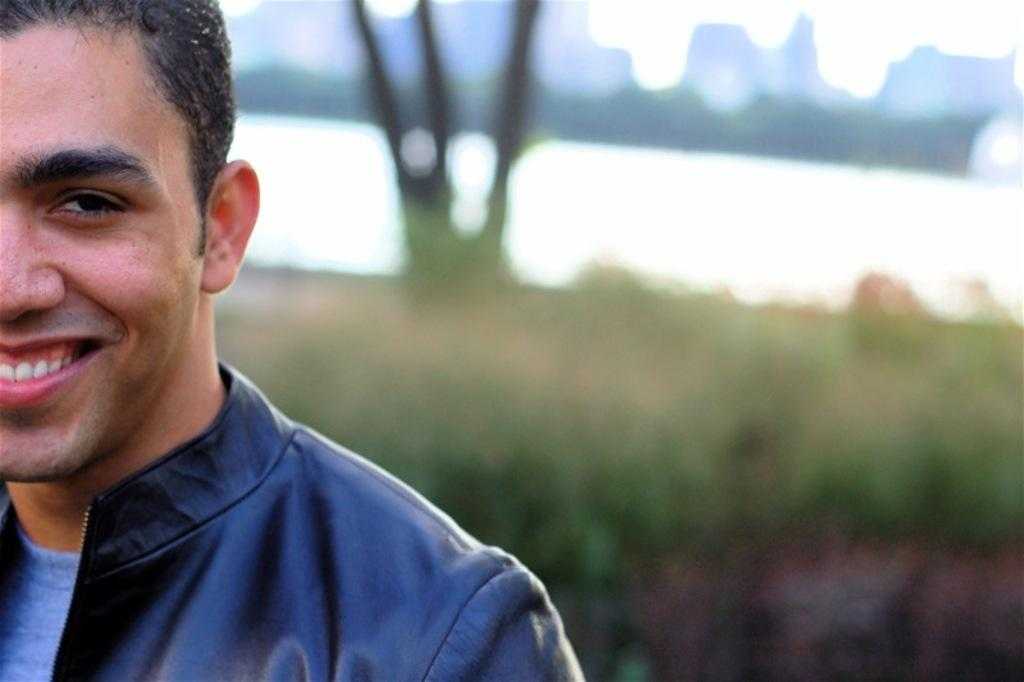What can be observed about the background of the image? The background portion of the picture is blurred. Can you describe the person in the image? There is a man in the image. What is the man wearing? The man is wearing a black jacket. What is the man's facial expression? The man is smiling. How many geese are present in the image? There are no geese present in the image; it features a man wearing a black jacket and smiling. What type of fruit is the man holding in the image? There is no fruit visible in the image; the man is not holding anything. 